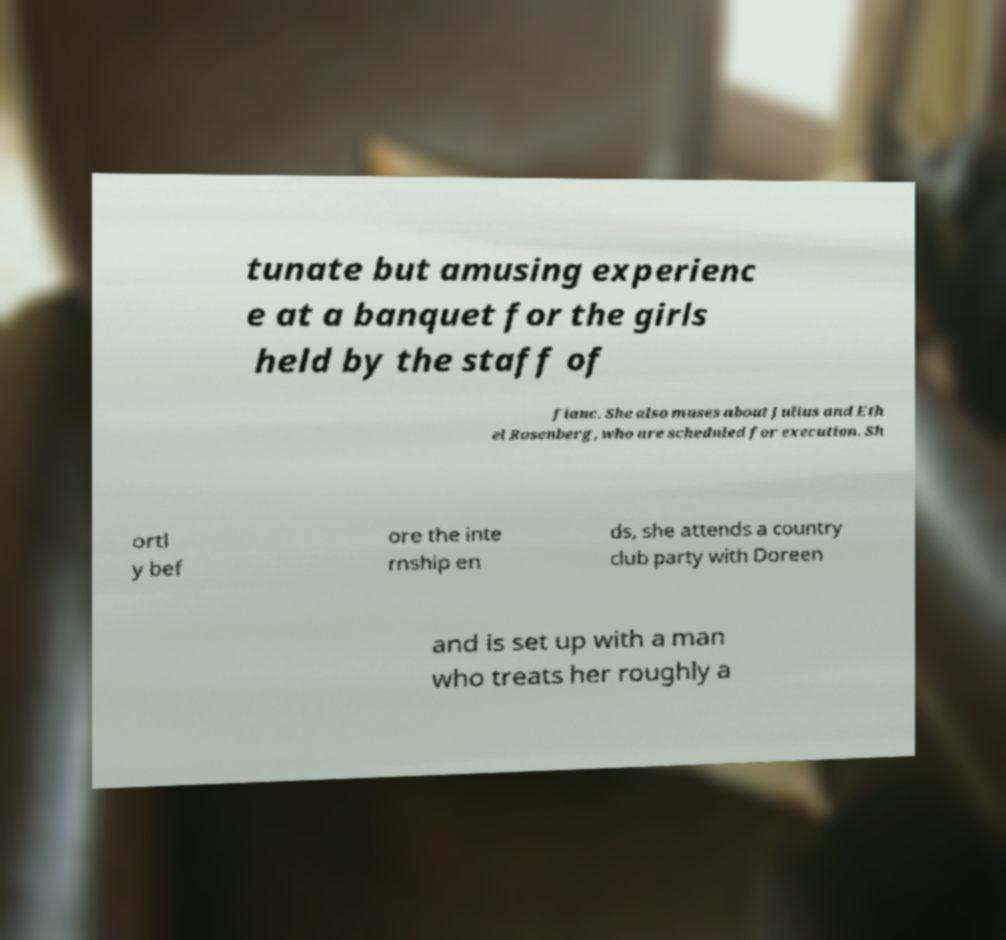Can you read and provide the text displayed in the image?This photo seems to have some interesting text. Can you extract and type it out for me? tunate but amusing experienc e at a banquet for the girls held by the staff of fianc. She also muses about Julius and Eth el Rosenberg, who are scheduled for execution. Sh ortl y bef ore the inte rnship en ds, she attends a country club party with Doreen and is set up with a man who treats her roughly a 